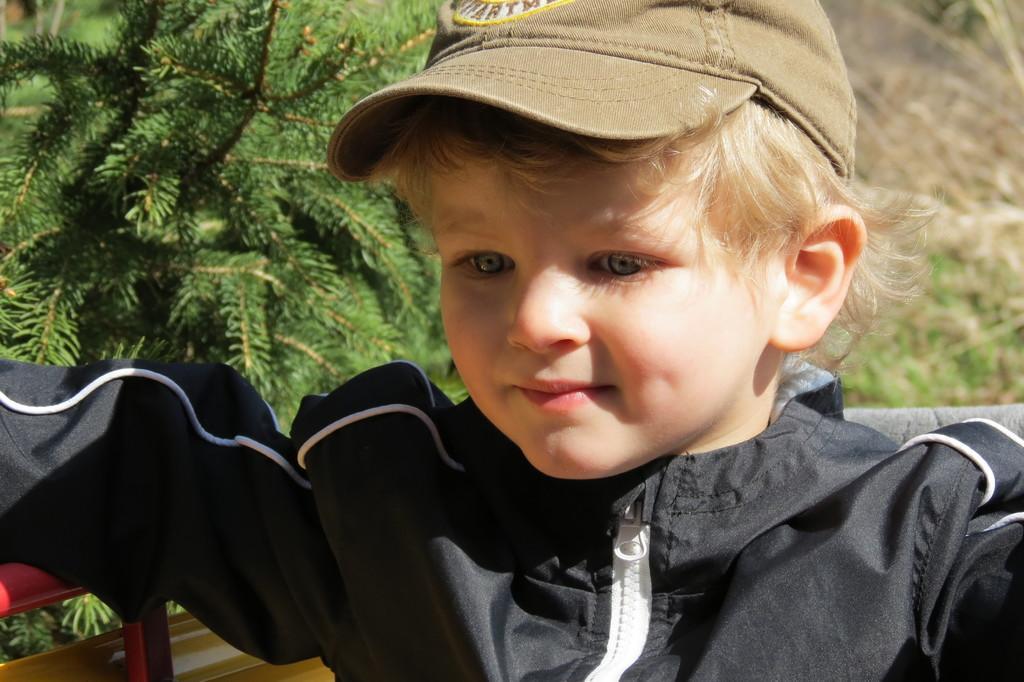Please provide a concise description of this image. In this image there is a kid in the middle who is wearing the black dress. In the background there is a plant. 